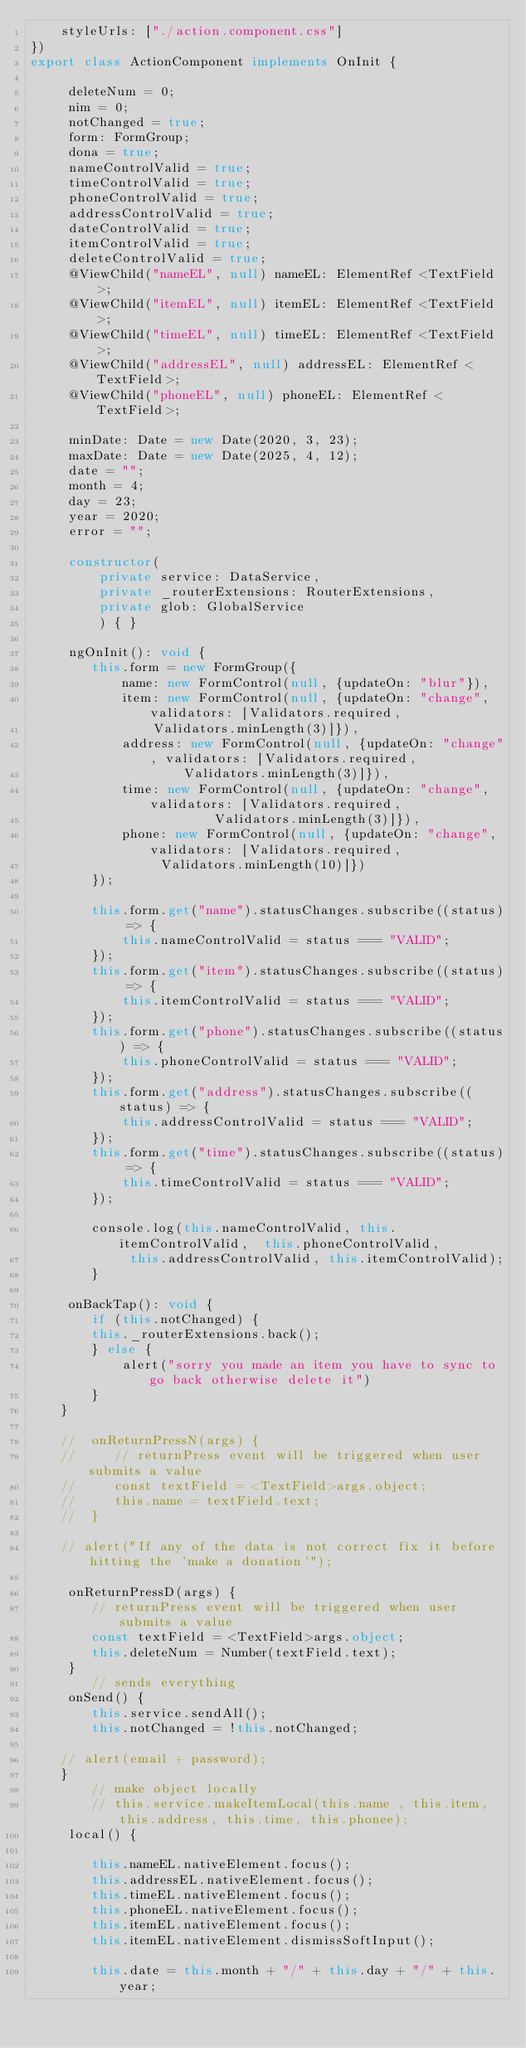<code> <loc_0><loc_0><loc_500><loc_500><_TypeScript_>    styleUrls: ["./action.component.css"]
})
export class ActionComponent implements OnInit {

     deleteNum = 0;
     nim = 0;
     notChanged = true;
     form: FormGroup;
     dona = true;
     nameControlValid = true;
     timeControlValid = true;
     phoneControlValid = true;
     addressControlValid = true;
     dateControlValid = true;
     itemControlValid = true;
     deleteControlValid = true;
     @ViewChild("nameEL", null) nameEL: ElementRef <TextField>;
     @ViewChild("itemEL", null) itemEL: ElementRef <TextField>;
     @ViewChild("timeEL", null) timeEL: ElementRef <TextField>;
     @ViewChild("addressEL", null) addressEL: ElementRef <TextField>;
     @ViewChild("phoneEL", null) phoneEL: ElementRef <TextField>;

     minDate: Date = new Date(2020, 3, 23);
     maxDate: Date = new Date(2025, 4, 12);
     date = "";
     month = 4;
     day = 23;
     year = 2020;
     error = "";

     constructor(
         private service: DataService,
         private _routerExtensions: RouterExtensions,
         private glob: GlobalService
         ) { }

     ngOnInit(): void {
        this.form = new FormGroup({
            name: new FormControl(null, {updateOn: "blur"}),
            item: new FormControl(null, {updateOn: "change", validators: [Validators.required,
                Validators.minLength(3)]}),
            address: new FormControl(null, {updateOn: "change", validators: [Validators.required,
                    Validators.minLength(3)]}),
            time: new FormControl(null, {updateOn: "change", validators: [Validators.required,
                        Validators.minLength(3)]}),
            phone: new FormControl(null, {updateOn: "change", validators: [Validators.required,
                 Validators.minLength(10)]})
        });

        this.form.get("name").statusChanges.subscribe((status) => {
            this.nameControlValid = status === "VALID";
        });
        this.form.get("item").statusChanges.subscribe((status) => {
            this.itemControlValid = status === "VALID";
        });
        this.form.get("phone").statusChanges.subscribe((status) => {
            this.phoneControlValid = status === "VALID";
        });
        this.form.get("address").statusChanges.subscribe((status) => {
            this.addressControlValid = status === "VALID";
        });
        this.form.get("time").statusChanges.subscribe((status) => {
            this.timeControlValid = status === "VALID";
        });

        console.log(this.nameControlValid, this.itemControlValid,  this.phoneControlValid,
             this.addressControlValid, this.itemControlValid);
        }

     onBackTap(): void {
        if (this.notChanged) {
        this._routerExtensions.back();
        } else {
            alert("sorry you made an item you have to sync to go back otherwise delete it")
        }
    }

    //  onReturnPressN(args) {
    //     // returnPress event will be triggered when user submits a value
    //     const textField = <TextField>args.object;
    //     this.name = textField.text;
    //  }

    // alert("If any of the data is not correct fix it before hitting the 'make a donation'");

     onReturnPressD(args) {
        // returnPress event will be triggered when user submits a value
        const textField = <TextField>args.object;
        this.deleteNum = Number(textField.text);
     }
        // sends everything
     onSend() {
        this.service.sendAll();
        this.notChanged = !this.notChanged;

    // alert(email + password);
    }
        // make object locally
        // this.service.makeItemLocal(this.name , this.item, this.address, this.time, this.phonee);
     local() {

        this.nameEL.nativeElement.focus();
        this.addressEL.nativeElement.focus();
        this.timeEL.nativeElement.focus();
        this.phoneEL.nativeElement.focus();
        this.itemEL.nativeElement.focus();
        this.itemEL.nativeElement.dismissSoftInput();

        this.date = this.month + "/" + this.day + "/" + this.year;
</code> 